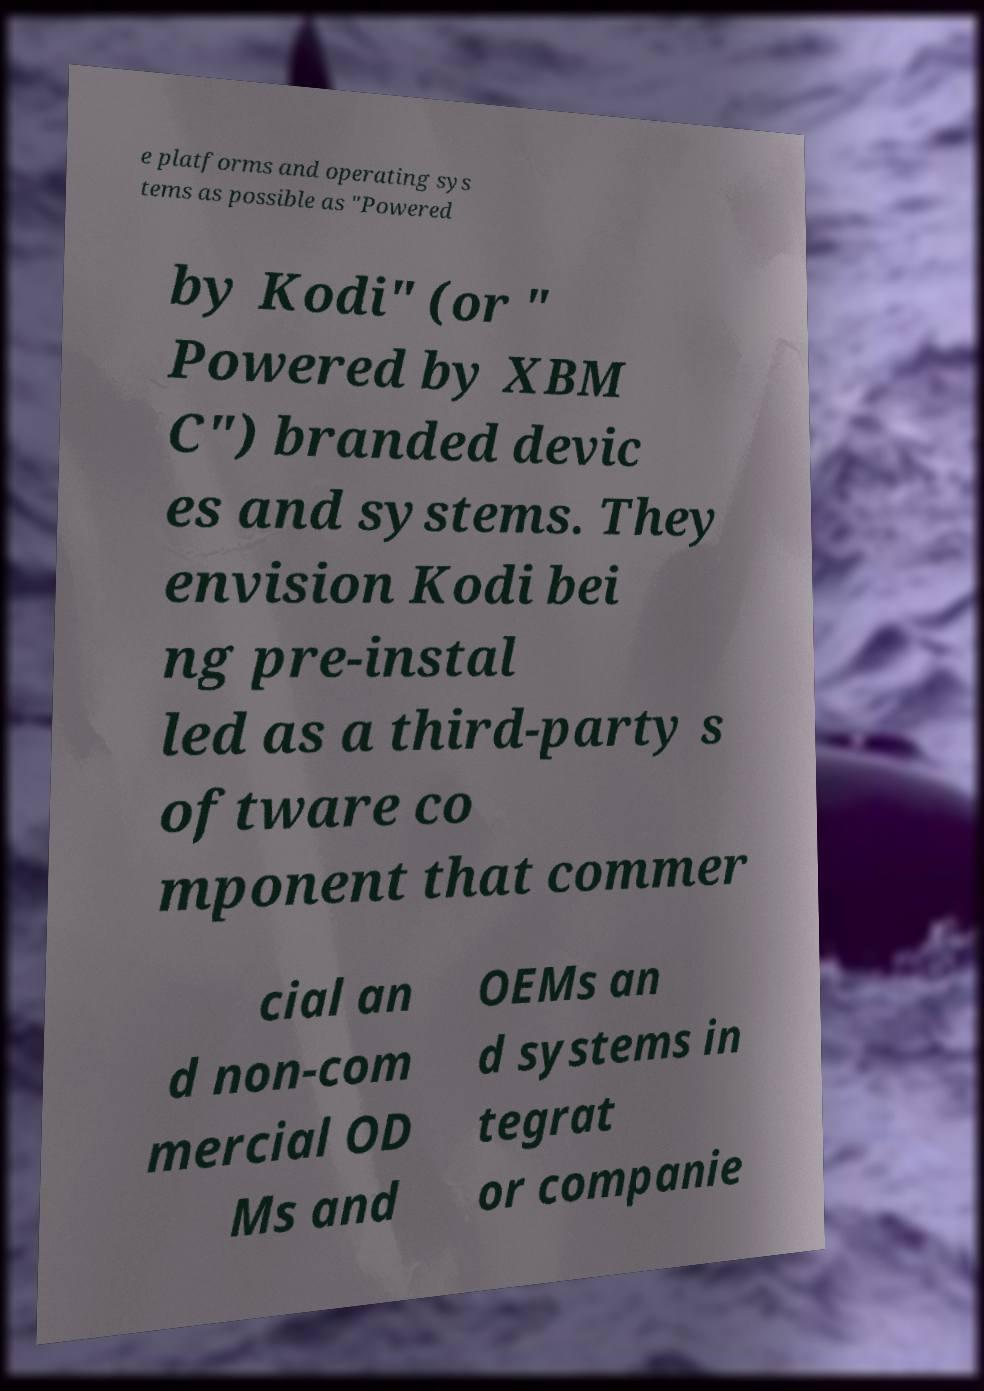Please read and relay the text visible in this image. What does it say? e platforms and operating sys tems as possible as "Powered by Kodi" (or " Powered by XBM C") branded devic es and systems. They envision Kodi bei ng pre-instal led as a third-party s oftware co mponent that commer cial an d non-com mercial OD Ms and OEMs an d systems in tegrat or companie 